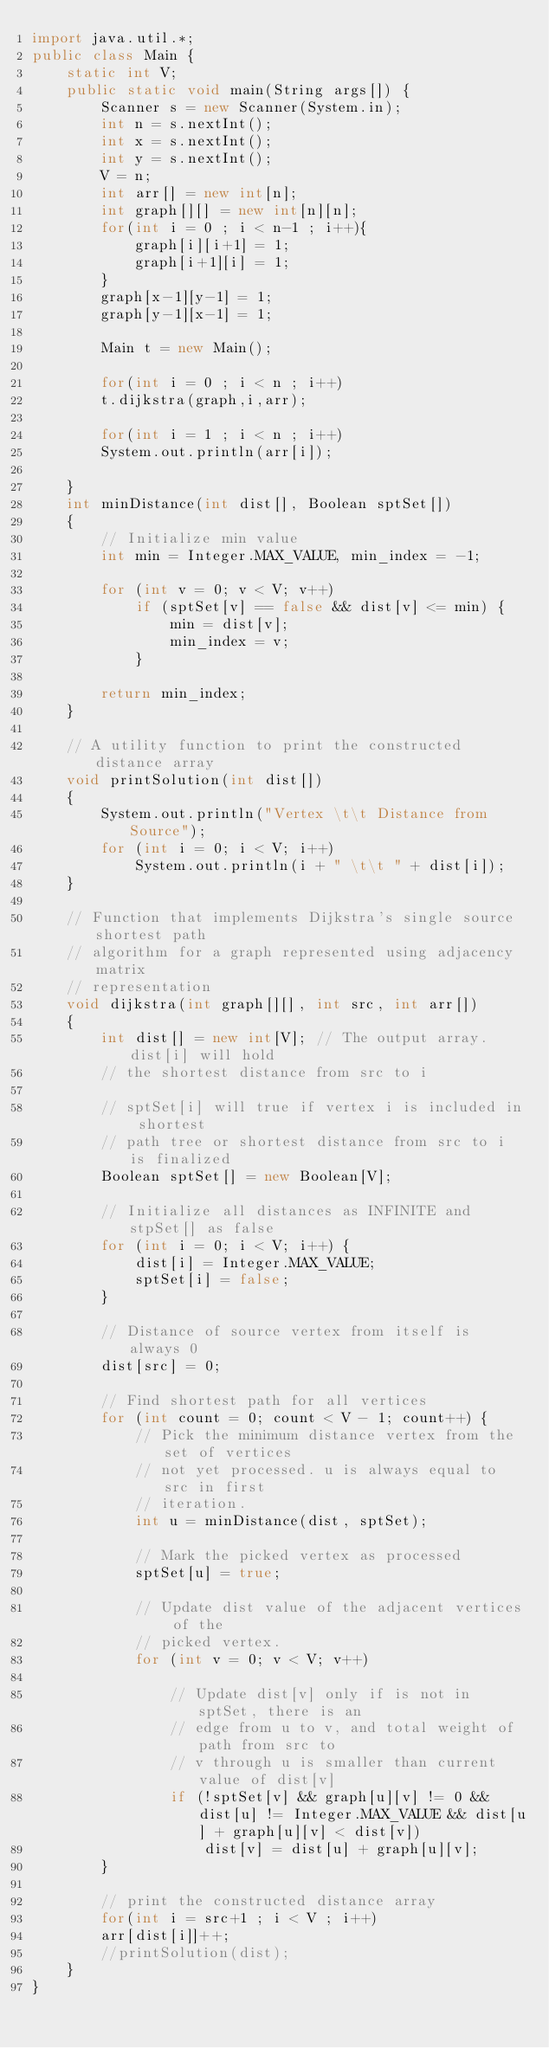Convert code to text. <code><loc_0><loc_0><loc_500><loc_500><_Java_>import java.util.*;
public class Main {
    static int V; 
    public static void main(String args[]) {
        Scanner s = new Scanner(System.in);
        int n = s.nextInt();
        int x = s.nextInt();
        int y = s.nextInt(); 
        V = n;
        int arr[] = new int[n];
        int graph[][] = new int[n][n];
        for(int i = 0 ; i < n-1 ; i++){
            graph[i][i+1] = 1;
            graph[i+1][i] = 1;
        }
        graph[x-1][y-1] = 1;
        graph[y-1][x-1] = 1;

        Main t = new Main();

        for(int i = 0 ; i < n ; i++)
        t.dijkstra(graph,i,arr);

        for(int i = 1 ; i < n ; i++)
        System.out.println(arr[i]); 

    }
    int minDistance(int dist[], Boolean sptSet[]) 
    { 
        // Initialize min value 
        int min = Integer.MAX_VALUE, min_index = -1; 
  
        for (int v = 0; v < V; v++) 
            if (sptSet[v] == false && dist[v] <= min) { 
                min = dist[v]; 
                min_index = v; 
            } 
  
        return min_index; 
    } 
  
    // A utility function to print the constructed distance array 
    void printSolution(int dist[]) 
    { 
        System.out.println("Vertex \t\t Distance from Source"); 
        for (int i = 0; i < V; i++) 
            System.out.println(i + " \t\t " + dist[i]); 
    } 
  
    // Function that implements Dijkstra's single source shortest path 
    // algorithm for a graph represented using adjacency matrix 
    // representation 
    void dijkstra(int graph[][], int src, int arr[]) 
    { 
        int dist[] = new int[V]; // The output array. dist[i] will hold 
        // the shortest distance from src to i 
  
        // sptSet[i] will true if vertex i is included in shortest 
        // path tree or shortest distance from src to i is finalized 
        Boolean sptSet[] = new Boolean[V]; 
  
        // Initialize all distances as INFINITE and stpSet[] as false 
        for (int i = 0; i < V; i++) { 
            dist[i] = Integer.MAX_VALUE; 
            sptSet[i] = false; 
        } 
  
        // Distance of source vertex from itself is always 0 
        dist[src] = 0; 
  
        // Find shortest path for all vertices 
        for (int count = 0; count < V - 1; count++) { 
            // Pick the minimum distance vertex from the set of vertices 
            // not yet processed. u is always equal to src in first 
            // iteration. 
            int u = minDistance(dist, sptSet); 
  
            // Mark the picked vertex as processed 
            sptSet[u] = true; 
  
            // Update dist value of the adjacent vertices of the 
            // picked vertex. 
            for (int v = 0; v < V; v++) 
  
                // Update dist[v] only if is not in sptSet, there is an 
                // edge from u to v, and total weight of path from src to 
                // v through u is smaller than current value of dist[v] 
                if (!sptSet[v] && graph[u][v] != 0 && dist[u] != Integer.MAX_VALUE && dist[u] + graph[u][v] < dist[v]) 
                    dist[v] = dist[u] + graph[u][v]; 
        } 
  
        // print the constructed distance array
        for(int i = src+1 ; i < V ; i++)
        arr[dist[i]]++;
        //printSolution(dist); 
    } 
}
</code> 